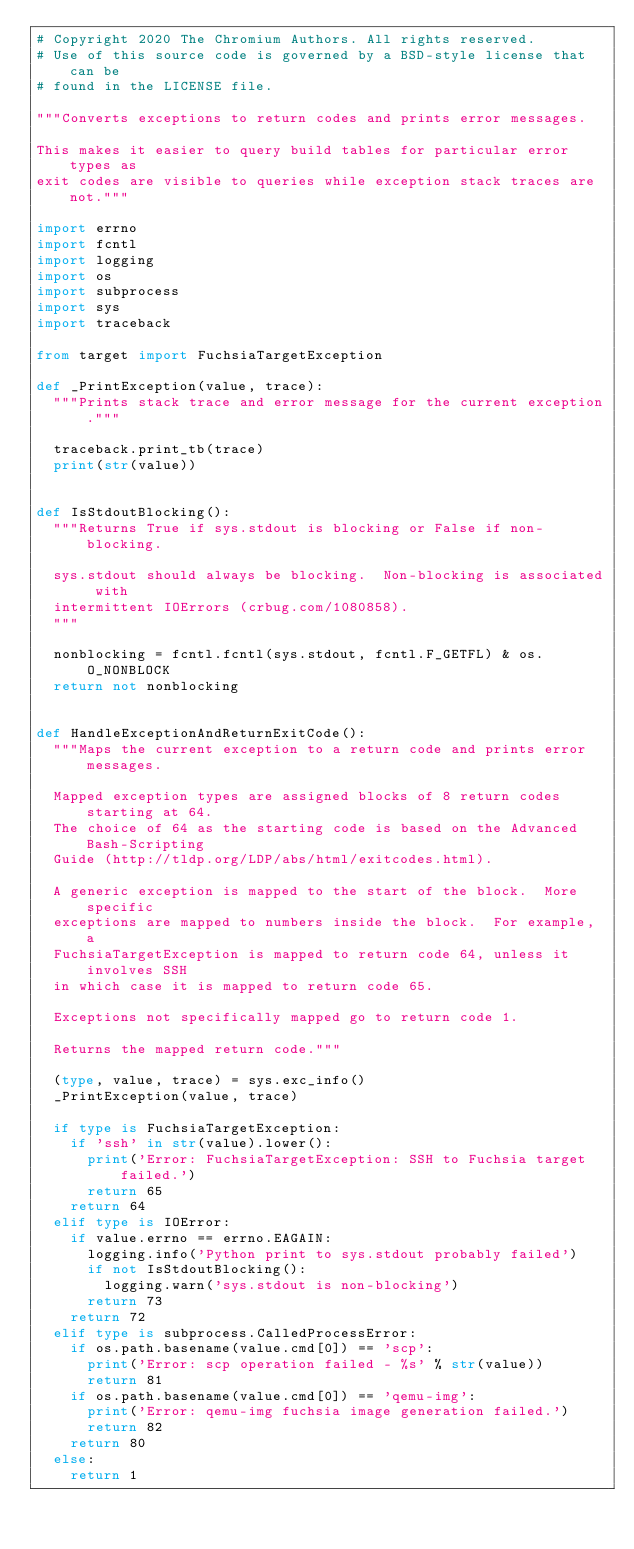Convert code to text. <code><loc_0><loc_0><loc_500><loc_500><_Python_># Copyright 2020 The Chromium Authors. All rights reserved.
# Use of this source code is governed by a BSD-style license that can be
# found in the LICENSE file.

"""Converts exceptions to return codes and prints error messages.

This makes it easier to query build tables for particular error types as
exit codes are visible to queries while exception stack traces are not."""

import errno
import fcntl
import logging
import os
import subprocess
import sys
import traceback

from target import FuchsiaTargetException

def _PrintException(value, trace):
  """Prints stack trace and error message for the current exception."""

  traceback.print_tb(trace)
  print(str(value))


def IsStdoutBlocking():
  """Returns True if sys.stdout is blocking or False if non-blocking.

  sys.stdout should always be blocking.  Non-blocking is associated with
  intermittent IOErrors (crbug.com/1080858).
  """

  nonblocking = fcntl.fcntl(sys.stdout, fcntl.F_GETFL) & os.O_NONBLOCK
  return not nonblocking


def HandleExceptionAndReturnExitCode():
  """Maps the current exception to a return code and prints error messages.

  Mapped exception types are assigned blocks of 8 return codes starting at 64.
  The choice of 64 as the starting code is based on the Advanced Bash-Scripting
  Guide (http://tldp.org/LDP/abs/html/exitcodes.html).

  A generic exception is mapped to the start of the block.  More specific
  exceptions are mapped to numbers inside the block.  For example, a
  FuchsiaTargetException is mapped to return code 64, unless it involves SSH
  in which case it is mapped to return code 65.

  Exceptions not specifically mapped go to return code 1.

  Returns the mapped return code."""

  (type, value, trace) = sys.exc_info()
  _PrintException(value, trace)

  if type is FuchsiaTargetException:
    if 'ssh' in str(value).lower():
      print('Error: FuchsiaTargetException: SSH to Fuchsia target failed.')
      return 65
    return 64
  elif type is IOError:
    if value.errno == errno.EAGAIN:
      logging.info('Python print to sys.stdout probably failed')
      if not IsStdoutBlocking():
        logging.warn('sys.stdout is non-blocking')
      return 73
    return 72
  elif type is subprocess.CalledProcessError:
    if os.path.basename(value.cmd[0]) == 'scp':
      print('Error: scp operation failed - %s' % str(value))
      return 81
    if os.path.basename(value.cmd[0]) == 'qemu-img':
      print('Error: qemu-img fuchsia image generation failed.')
      return 82
    return 80
  else:
    return 1
</code> 